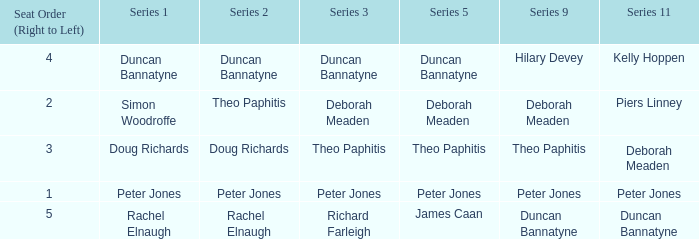How many Seat Orders (Right to Left) have a Series 3 of deborah meaden? 1.0. 